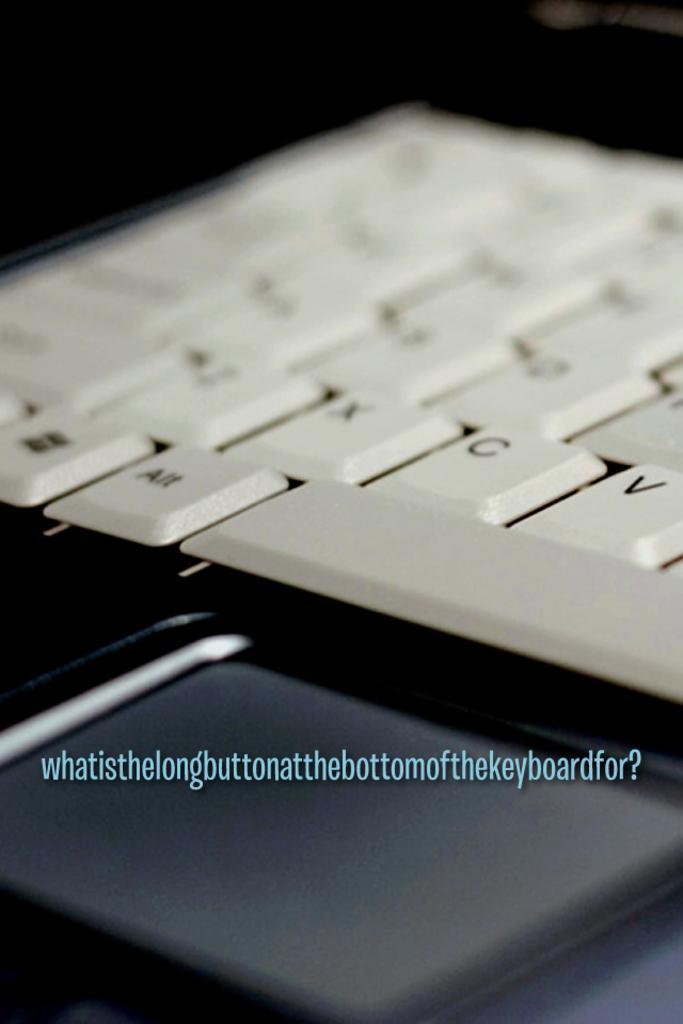Describe this image in one or two sentences. This is a zoomed in picture. In the center there is a white color keyboard. In the foreground there is a black color object and we can see the text on the image. 